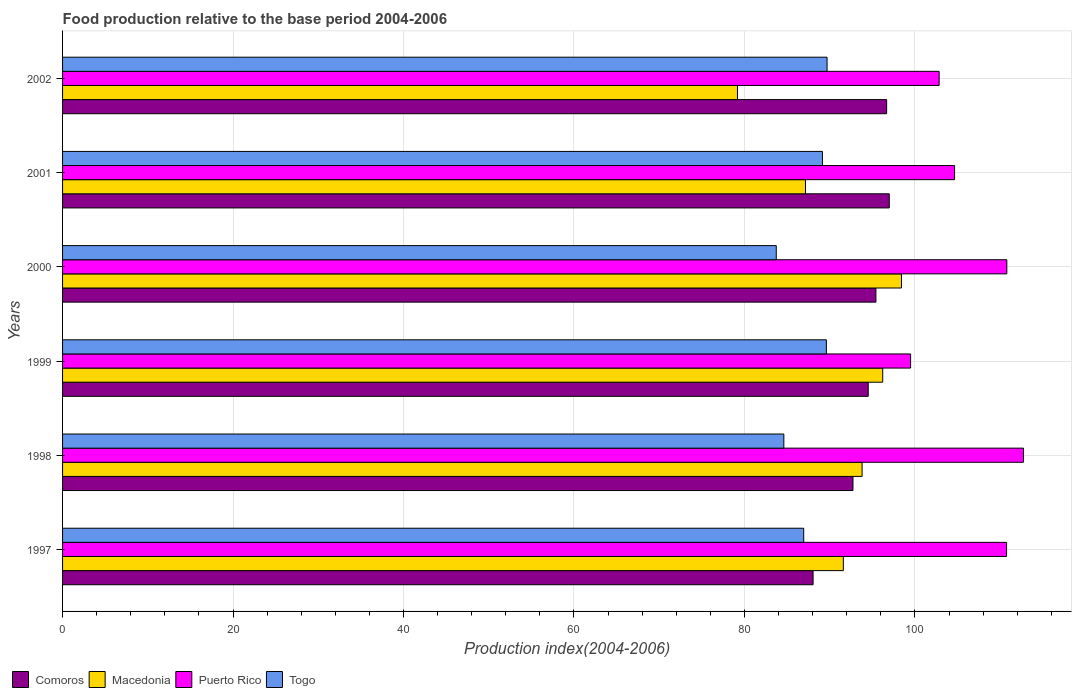How many groups of bars are there?
Your answer should be compact. 6. How many bars are there on the 1st tick from the top?
Your response must be concise. 4. What is the food production index in Comoros in 1999?
Your answer should be very brief. 94.52. Across all years, what is the maximum food production index in Togo?
Provide a short and direct response. 89.69. Across all years, what is the minimum food production index in Puerto Rico?
Provide a succinct answer. 99.49. In which year was the food production index in Puerto Rico minimum?
Make the answer very short. 1999. What is the total food production index in Puerto Rico in the graph?
Your answer should be very brief. 641.24. What is the difference between the food production index in Macedonia in 1998 and that in 1999?
Provide a succinct answer. -2.42. What is the difference between the food production index in Puerto Rico in 1999 and the food production index in Macedonia in 2001?
Your answer should be very brief. 12.33. What is the average food production index in Macedonia per year?
Your response must be concise. 91.06. In the year 2001, what is the difference between the food production index in Comoros and food production index in Puerto Rico?
Keep it short and to the point. -7.66. In how many years, is the food production index in Puerto Rico greater than 48 ?
Provide a short and direct response. 6. What is the ratio of the food production index in Togo in 1999 to that in 2002?
Provide a succinct answer. 1. Is the food production index in Comoros in 1998 less than that in 2002?
Ensure brevity in your answer.  Yes. Is the difference between the food production index in Comoros in 1999 and 2002 greater than the difference between the food production index in Puerto Rico in 1999 and 2002?
Offer a terse response. Yes. What is the difference between the highest and the second highest food production index in Macedonia?
Provide a succinct answer. 2.2. What is the difference between the highest and the lowest food production index in Macedonia?
Keep it short and to the point. 19.24. In how many years, is the food production index in Macedonia greater than the average food production index in Macedonia taken over all years?
Provide a succinct answer. 4. Is the sum of the food production index in Puerto Rico in 1998 and 2000 greater than the maximum food production index in Togo across all years?
Provide a short and direct response. Yes. What does the 3rd bar from the top in 1998 represents?
Provide a short and direct response. Macedonia. What does the 3rd bar from the bottom in 1999 represents?
Keep it short and to the point. Puerto Rico. Are all the bars in the graph horizontal?
Offer a terse response. Yes. What is the difference between two consecutive major ticks on the X-axis?
Your response must be concise. 20. What is the title of the graph?
Your response must be concise. Food production relative to the base period 2004-2006. Does "Lithuania" appear as one of the legend labels in the graph?
Your response must be concise. No. What is the label or title of the X-axis?
Your answer should be very brief. Production index(2004-2006). What is the label or title of the Y-axis?
Give a very brief answer. Years. What is the Production index(2004-2006) of Comoros in 1997?
Provide a succinct answer. 88.05. What is the Production index(2004-2006) of Macedonia in 1997?
Your response must be concise. 91.6. What is the Production index(2004-2006) of Puerto Rico in 1997?
Give a very brief answer. 110.75. What is the Production index(2004-2006) in Togo in 1997?
Provide a short and direct response. 86.95. What is the Production index(2004-2006) in Comoros in 1998?
Your answer should be very brief. 92.73. What is the Production index(2004-2006) of Macedonia in 1998?
Provide a short and direct response. 93.8. What is the Production index(2004-2006) of Puerto Rico in 1998?
Ensure brevity in your answer.  112.73. What is the Production index(2004-2006) of Togo in 1998?
Give a very brief answer. 84.62. What is the Production index(2004-2006) in Comoros in 1999?
Provide a short and direct response. 94.52. What is the Production index(2004-2006) of Macedonia in 1999?
Ensure brevity in your answer.  96.22. What is the Production index(2004-2006) of Puerto Rico in 1999?
Offer a very short reply. 99.49. What is the Production index(2004-2006) in Togo in 1999?
Offer a terse response. 89.61. What is the Production index(2004-2006) in Comoros in 2000?
Your answer should be compact. 95.42. What is the Production index(2004-2006) in Macedonia in 2000?
Make the answer very short. 98.42. What is the Production index(2004-2006) of Puerto Rico in 2000?
Provide a short and direct response. 110.78. What is the Production index(2004-2006) in Togo in 2000?
Offer a terse response. 83.73. What is the Production index(2004-2006) in Comoros in 2001?
Make the answer very short. 96.99. What is the Production index(2004-2006) of Macedonia in 2001?
Keep it short and to the point. 87.16. What is the Production index(2004-2006) of Puerto Rico in 2001?
Your answer should be very brief. 104.65. What is the Production index(2004-2006) of Togo in 2001?
Keep it short and to the point. 89.15. What is the Production index(2004-2006) of Comoros in 2002?
Your response must be concise. 96.68. What is the Production index(2004-2006) of Macedonia in 2002?
Give a very brief answer. 79.18. What is the Production index(2004-2006) in Puerto Rico in 2002?
Ensure brevity in your answer.  102.84. What is the Production index(2004-2006) of Togo in 2002?
Offer a terse response. 89.69. Across all years, what is the maximum Production index(2004-2006) of Comoros?
Give a very brief answer. 96.99. Across all years, what is the maximum Production index(2004-2006) in Macedonia?
Offer a terse response. 98.42. Across all years, what is the maximum Production index(2004-2006) of Puerto Rico?
Make the answer very short. 112.73. Across all years, what is the maximum Production index(2004-2006) of Togo?
Offer a very short reply. 89.69. Across all years, what is the minimum Production index(2004-2006) in Comoros?
Ensure brevity in your answer.  88.05. Across all years, what is the minimum Production index(2004-2006) of Macedonia?
Provide a succinct answer. 79.18. Across all years, what is the minimum Production index(2004-2006) of Puerto Rico?
Your response must be concise. 99.49. Across all years, what is the minimum Production index(2004-2006) of Togo?
Your answer should be very brief. 83.73. What is the total Production index(2004-2006) of Comoros in the graph?
Offer a very short reply. 564.39. What is the total Production index(2004-2006) in Macedonia in the graph?
Offer a very short reply. 546.38. What is the total Production index(2004-2006) in Puerto Rico in the graph?
Make the answer very short. 641.24. What is the total Production index(2004-2006) in Togo in the graph?
Make the answer very short. 523.75. What is the difference between the Production index(2004-2006) in Comoros in 1997 and that in 1998?
Offer a very short reply. -4.68. What is the difference between the Production index(2004-2006) of Macedonia in 1997 and that in 1998?
Offer a terse response. -2.2. What is the difference between the Production index(2004-2006) of Puerto Rico in 1997 and that in 1998?
Your answer should be compact. -1.98. What is the difference between the Production index(2004-2006) of Togo in 1997 and that in 1998?
Your answer should be compact. 2.33. What is the difference between the Production index(2004-2006) of Comoros in 1997 and that in 1999?
Your response must be concise. -6.47. What is the difference between the Production index(2004-2006) in Macedonia in 1997 and that in 1999?
Your answer should be very brief. -4.62. What is the difference between the Production index(2004-2006) of Puerto Rico in 1997 and that in 1999?
Your response must be concise. 11.26. What is the difference between the Production index(2004-2006) of Togo in 1997 and that in 1999?
Offer a terse response. -2.66. What is the difference between the Production index(2004-2006) in Comoros in 1997 and that in 2000?
Your answer should be compact. -7.37. What is the difference between the Production index(2004-2006) of Macedonia in 1997 and that in 2000?
Ensure brevity in your answer.  -6.82. What is the difference between the Production index(2004-2006) in Puerto Rico in 1997 and that in 2000?
Your answer should be compact. -0.03. What is the difference between the Production index(2004-2006) of Togo in 1997 and that in 2000?
Provide a succinct answer. 3.22. What is the difference between the Production index(2004-2006) in Comoros in 1997 and that in 2001?
Offer a very short reply. -8.94. What is the difference between the Production index(2004-2006) in Macedonia in 1997 and that in 2001?
Your answer should be compact. 4.44. What is the difference between the Production index(2004-2006) in Comoros in 1997 and that in 2002?
Ensure brevity in your answer.  -8.63. What is the difference between the Production index(2004-2006) of Macedonia in 1997 and that in 2002?
Your answer should be very brief. 12.42. What is the difference between the Production index(2004-2006) of Puerto Rico in 1997 and that in 2002?
Provide a short and direct response. 7.91. What is the difference between the Production index(2004-2006) of Togo in 1997 and that in 2002?
Keep it short and to the point. -2.74. What is the difference between the Production index(2004-2006) of Comoros in 1998 and that in 1999?
Offer a terse response. -1.79. What is the difference between the Production index(2004-2006) in Macedonia in 1998 and that in 1999?
Provide a succinct answer. -2.42. What is the difference between the Production index(2004-2006) of Puerto Rico in 1998 and that in 1999?
Offer a very short reply. 13.24. What is the difference between the Production index(2004-2006) of Togo in 1998 and that in 1999?
Your answer should be very brief. -4.99. What is the difference between the Production index(2004-2006) of Comoros in 1998 and that in 2000?
Your answer should be very brief. -2.69. What is the difference between the Production index(2004-2006) of Macedonia in 1998 and that in 2000?
Keep it short and to the point. -4.62. What is the difference between the Production index(2004-2006) in Puerto Rico in 1998 and that in 2000?
Your response must be concise. 1.95. What is the difference between the Production index(2004-2006) of Togo in 1998 and that in 2000?
Provide a succinct answer. 0.89. What is the difference between the Production index(2004-2006) of Comoros in 1998 and that in 2001?
Your response must be concise. -4.26. What is the difference between the Production index(2004-2006) in Macedonia in 1998 and that in 2001?
Your answer should be very brief. 6.64. What is the difference between the Production index(2004-2006) in Puerto Rico in 1998 and that in 2001?
Your response must be concise. 8.08. What is the difference between the Production index(2004-2006) in Togo in 1998 and that in 2001?
Ensure brevity in your answer.  -4.53. What is the difference between the Production index(2004-2006) in Comoros in 1998 and that in 2002?
Provide a short and direct response. -3.95. What is the difference between the Production index(2004-2006) of Macedonia in 1998 and that in 2002?
Make the answer very short. 14.62. What is the difference between the Production index(2004-2006) in Puerto Rico in 1998 and that in 2002?
Offer a terse response. 9.89. What is the difference between the Production index(2004-2006) in Togo in 1998 and that in 2002?
Keep it short and to the point. -5.07. What is the difference between the Production index(2004-2006) in Macedonia in 1999 and that in 2000?
Ensure brevity in your answer.  -2.2. What is the difference between the Production index(2004-2006) in Puerto Rico in 1999 and that in 2000?
Keep it short and to the point. -11.29. What is the difference between the Production index(2004-2006) of Togo in 1999 and that in 2000?
Offer a terse response. 5.88. What is the difference between the Production index(2004-2006) in Comoros in 1999 and that in 2001?
Keep it short and to the point. -2.47. What is the difference between the Production index(2004-2006) in Macedonia in 1999 and that in 2001?
Offer a terse response. 9.06. What is the difference between the Production index(2004-2006) in Puerto Rico in 1999 and that in 2001?
Your response must be concise. -5.16. What is the difference between the Production index(2004-2006) of Togo in 1999 and that in 2001?
Offer a very short reply. 0.46. What is the difference between the Production index(2004-2006) of Comoros in 1999 and that in 2002?
Provide a succinct answer. -2.16. What is the difference between the Production index(2004-2006) in Macedonia in 1999 and that in 2002?
Provide a succinct answer. 17.04. What is the difference between the Production index(2004-2006) of Puerto Rico in 1999 and that in 2002?
Ensure brevity in your answer.  -3.35. What is the difference between the Production index(2004-2006) in Togo in 1999 and that in 2002?
Make the answer very short. -0.08. What is the difference between the Production index(2004-2006) in Comoros in 2000 and that in 2001?
Your answer should be compact. -1.57. What is the difference between the Production index(2004-2006) of Macedonia in 2000 and that in 2001?
Provide a short and direct response. 11.26. What is the difference between the Production index(2004-2006) in Puerto Rico in 2000 and that in 2001?
Ensure brevity in your answer.  6.13. What is the difference between the Production index(2004-2006) of Togo in 2000 and that in 2001?
Your response must be concise. -5.42. What is the difference between the Production index(2004-2006) of Comoros in 2000 and that in 2002?
Your response must be concise. -1.26. What is the difference between the Production index(2004-2006) of Macedonia in 2000 and that in 2002?
Offer a very short reply. 19.24. What is the difference between the Production index(2004-2006) in Puerto Rico in 2000 and that in 2002?
Offer a very short reply. 7.94. What is the difference between the Production index(2004-2006) of Togo in 2000 and that in 2002?
Provide a succinct answer. -5.96. What is the difference between the Production index(2004-2006) in Comoros in 2001 and that in 2002?
Provide a short and direct response. 0.31. What is the difference between the Production index(2004-2006) of Macedonia in 2001 and that in 2002?
Make the answer very short. 7.98. What is the difference between the Production index(2004-2006) of Puerto Rico in 2001 and that in 2002?
Provide a short and direct response. 1.81. What is the difference between the Production index(2004-2006) in Togo in 2001 and that in 2002?
Provide a short and direct response. -0.54. What is the difference between the Production index(2004-2006) in Comoros in 1997 and the Production index(2004-2006) in Macedonia in 1998?
Offer a terse response. -5.75. What is the difference between the Production index(2004-2006) of Comoros in 1997 and the Production index(2004-2006) of Puerto Rico in 1998?
Give a very brief answer. -24.68. What is the difference between the Production index(2004-2006) of Comoros in 1997 and the Production index(2004-2006) of Togo in 1998?
Ensure brevity in your answer.  3.43. What is the difference between the Production index(2004-2006) in Macedonia in 1997 and the Production index(2004-2006) in Puerto Rico in 1998?
Your answer should be compact. -21.13. What is the difference between the Production index(2004-2006) of Macedonia in 1997 and the Production index(2004-2006) of Togo in 1998?
Provide a succinct answer. 6.98. What is the difference between the Production index(2004-2006) in Puerto Rico in 1997 and the Production index(2004-2006) in Togo in 1998?
Keep it short and to the point. 26.13. What is the difference between the Production index(2004-2006) in Comoros in 1997 and the Production index(2004-2006) in Macedonia in 1999?
Ensure brevity in your answer.  -8.17. What is the difference between the Production index(2004-2006) of Comoros in 1997 and the Production index(2004-2006) of Puerto Rico in 1999?
Your answer should be compact. -11.44. What is the difference between the Production index(2004-2006) of Comoros in 1997 and the Production index(2004-2006) of Togo in 1999?
Your answer should be compact. -1.56. What is the difference between the Production index(2004-2006) of Macedonia in 1997 and the Production index(2004-2006) of Puerto Rico in 1999?
Offer a terse response. -7.89. What is the difference between the Production index(2004-2006) of Macedonia in 1997 and the Production index(2004-2006) of Togo in 1999?
Keep it short and to the point. 1.99. What is the difference between the Production index(2004-2006) in Puerto Rico in 1997 and the Production index(2004-2006) in Togo in 1999?
Offer a very short reply. 21.14. What is the difference between the Production index(2004-2006) of Comoros in 1997 and the Production index(2004-2006) of Macedonia in 2000?
Your answer should be very brief. -10.37. What is the difference between the Production index(2004-2006) in Comoros in 1997 and the Production index(2004-2006) in Puerto Rico in 2000?
Your response must be concise. -22.73. What is the difference between the Production index(2004-2006) of Comoros in 1997 and the Production index(2004-2006) of Togo in 2000?
Provide a succinct answer. 4.32. What is the difference between the Production index(2004-2006) in Macedonia in 1997 and the Production index(2004-2006) in Puerto Rico in 2000?
Give a very brief answer. -19.18. What is the difference between the Production index(2004-2006) of Macedonia in 1997 and the Production index(2004-2006) of Togo in 2000?
Your response must be concise. 7.87. What is the difference between the Production index(2004-2006) of Puerto Rico in 1997 and the Production index(2004-2006) of Togo in 2000?
Provide a succinct answer. 27.02. What is the difference between the Production index(2004-2006) of Comoros in 1997 and the Production index(2004-2006) of Macedonia in 2001?
Make the answer very short. 0.89. What is the difference between the Production index(2004-2006) of Comoros in 1997 and the Production index(2004-2006) of Puerto Rico in 2001?
Provide a succinct answer. -16.6. What is the difference between the Production index(2004-2006) in Comoros in 1997 and the Production index(2004-2006) in Togo in 2001?
Offer a terse response. -1.1. What is the difference between the Production index(2004-2006) of Macedonia in 1997 and the Production index(2004-2006) of Puerto Rico in 2001?
Ensure brevity in your answer.  -13.05. What is the difference between the Production index(2004-2006) of Macedonia in 1997 and the Production index(2004-2006) of Togo in 2001?
Provide a succinct answer. 2.45. What is the difference between the Production index(2004-2006) in Puerto Rico in 1997 and the Production index(2004-2006) in Togo in 2001?
Your answer should be very brief. 21.6. What is the difference between the Production index(2004-2006) of Comoros in 1997 and the Production index(2004-2006) of Macedonia in 2002?
Your response must be concise. 8.87. What is the difference between the Production index(2004-2006) of Comoros in 1997 and the Production index(2004-2006) of Puerto Rico in 2002?
Your answer should be compact. -14.79. What is the difference between the Production index(2004-2006) in Comoros in 1997 and the Production index(2004-2006) in Togo in 2002?
Ensure brevity in your answer.  -1.64. What is the difference between the Production index(2004-2006) of Macedonia in 1997 and the Production index(2004-2006) of Puerto Rico in 2002?
Make the answer very short. -11.24. What is the difference between the Production index(2004-2006) in Macedonia in 1997 and the Production index(2004-2006) in Togo in 2002?
Your answer should be very brief. 1.91. What is the difference between the Production index(2004-2006) in Puerto Rico in 1997 and the Production index(2004-2006) in Togo in 2002?
Your answer should be very brief. 21.06. What is the difference between the Production index(2004-2006) in Comoros in 1998 and the Production index(2004-2006) in Macedonia in 1999?
Your response must be concise. -3.49. What is the difference between the Production index(2004-2006) of Comoros in 1998 and the Production index(2004-2006) of Puerto Rico in 1999?
Offer a very short reply. -6.76. What is the difference between the Production index(2004-2006) in Comoros in 1998 and the Production index(2004-2006) in Togo in 1999?
Provide a short and direct response. 3.12. What is the difference between the Production index(2004-2006) in Macedonia in 1998 and the Production index(2004-2006) in Puerto Rico in 1999?
Your answer should be compact. -5.69. What is the difference between the Production index(2004-2006) of Macedonia in 1998 and the Production index(2004-2006) of Togo in 1999?
Provide a short and direct response. 4.19. What is the difference between the Production index(2004-2006) in Puerto Rico in 1998 and the Production index(2004-2006) in Togo in 1999?
Your response must be concise. 23.12. What is the difference between the Production index(2004-2006) of Comoros in 1998 and the Production index(2004-2006) of Macedonia in 2000?
Offer a very short reply. -5.69. What is the difference between the Production index(2004-2006) of Comoros in 1998 and the Production index(2004-2006) of Puerto Rico in 2000?
Keep it short and to the point. -18.05. What is the difference between the Production index(2004-2006) in Comoros in 1998 and the Production index(2004-2006) in Togo in 2000?
Your answer should be very brief. 9. What is the difference between the Production index(2004-2006) in Macedonia in 1998 and the Production index(2004-2006) in Puerto Rico in 2000?
Your answer should be compact. -16.98. What is the difference between the Production index(2004-2006) in Macedonia in 1998 and the Production index(2004-2006) in Togo in 2000?
Offer a terse response. 10.07. What is the difference between the Production index(2004-2006) in Comoros in 1998 and the Production index(2004-2006) in Macedonia in 2001?
Keep it short and to the point. 5.57. What is the difference between the Production index(2004-2006) in Comoros in 1998 and the Production index(2004-2006) in Puerto Rico in 2001?
Your response must be concise. -11.92. What is the difference between the Production index(2004-2006) of Comoros in 1998 and the Production index(2004-2006) of Togo in 2001?
Your answer should be very brief. 3.58. What is the difference between the Production index(2004-2006) in Macedonia in 1998 and the Production index(2004-2006) in Puerto Rico in 2001?
Keep it short and to the point. -10.85. What is the difference between the Production index(2004-2006) in Macedonia in 1998 and the Production index(2004-2006) in Togo in 2001?
Make the answer very short. 4.65. What is the difference between the Production index(2004-2006) of Puerto Rico in 1998 and the Production index(2004-2006) of Togo in 2001?
Offer a very short reply. 23.58. What is the difference between the Production index(2004-2006) in Comoros in 1998 and the Production index(2004-2006) in Macedonia in 2002?
Your response must be concise. 13.55. What is the difference between the Production index(2004-2006) in Comoros in 1998 and the Production index(2004-2006) in Puerto Rico in 2002?
Offer a terse response. -10.11. What is the difference between the Production index(2004-2006) in Comoros in 1998 and the Production index(2004-2006) in Togo in 2002?
Offer a terse response. 3.04. What is the difference between the Production index(2004-2006) of Macedonia in 1998 and the Production index(2004-2006) of Puerto Rico in 2002?
Provide a succinct answer. -9.04. What is the difference between the Production index(2004-2006) in Macedonia in 1998 and the Production index(2004-2006) in Togo in 2002?
Give a very brief answer. 4.11. What is the difference between the Production index(2004-2006) in Puerto Rico in 1998 and the Production index(2004-2006) in Togo in 2002?
Offer a very short reply. 23.04. What is the difference between the Production index(2004-2006) in Comoros in 1999 and the Production index(2004-2006) in Macedonia in 2000?
Your response must be concise. -3.9. What is the difference between the Production index(2004-2006) of Comoros in 1999 and the Production index(2004-2006) of Puerto Rico in 2000?
Keep it short and to the point. -16.26. What is the difference between the Production index(2004-2006) in Comoros in 1999 and the Production index(2004-2006) in Togo in 2000?
Make the answer very short. 10.79. What is the difference between the Production index(2004-2006) of Macedonia in 1999 and the Production index(2004-2006) of Puerto Rico in 2000?
Offer a terse response. -14.56. What is the difference between the Production index(2004-2006) of Macedonia in 1999 and the Production index(2004-2006) of Togo in 2000?
Your answer should be compact. 12.49. What is the difference between the Production index(2004-2006) of Puerto Rico in 1999 and the Production index(2004-2006) of Togo in 2000?
Ensure brevity in your answer.  15.76. What is the difference between the Production index(2004-2006) of Comoros in 1999 and the Production index(2004-2006) of Macedonia in 2001?
Your answer should be compact. 7.36. What is the difference between the Production index(2004-2006) of Comoros in 1999 and the Production index(2004-2006) of Puerto Rico in 2001?
Offer a very short reply. -10.13. What is the difference between the Production index(2004-2006) of Comoros in 1999 and the Production index(2004-2006) of Togo in 2001?
Provide a short and direct response. 5.37. What is the difference between the Production index(2004-2006) of Macedonia in 1999 and the Production index(2004-2006) of Puerto Rico in 2001?
Offer a very short reply. -8.43. What is the difference between the Production index(2004-2006) of Macedonia in 1999 and the Production index(2004-2006) of Togo in 2001?
Offer a terse response. 7.07. What is the difference between the Production index(2004-2006) of Puerto Rico in 1999 and the Production index(2004-2006) of Togo in 2001?
Make the answer very short. 10.34. What is the difference between the Production index(2004-2006) of Comoros in 1999 and the Production index(2004-2006) of Macedonia in 2002?
Provide a succinct answer. 15.34. What is the difference between the Production index(2004-2006) in Comoros in 1999 and the Production index(2004-2006) in Puerto Rico in 2002?
Provide a succinct answer. -8.32. What is the difference between the Production index(2004-2006) in Comoros in 1999 and the Production index(2004-2006) in Togo in 2002?
Offer a very short reply. 4.83. What is the difference between the Production index(2004-2006) of Macedonia in 1999 and the Production index(2004-2006) of Puerto Rico in 2002?
Provide a succinct answer. -6.62. What is the difference between the Production index(2004-2006) of Macedonia in 1999 and the Production index(2004-2006) of Togo in 2002?
Ensure brevity in your answer.  6.53. What is the difference between the Production index(2004-2006) of Puerto Rico in 1999 and the Production index(2004-2006) of Togo in 2002?
Offer a very short reply. 9.8. What is the difference between the Production index(2004-2006) in Comoros in 2000 and the Production index(2004-2006) in Macedonia in 2001?
Offer a very short reply. 8.26. What is the difference between the Production index(2004-2006) in Comoros in 2000 and the Production index(2004-2006) in Puerto Rico in 2001?
Offer a very short reply. -9.23. What is the difference between the Production index(2004-2006) in Comoros in 2000 and the Production index(2004-2006) in Togo in 2001?
Keep it short and to the point. 6.27. What is the difference between the Production index(2004-2006) in Macedonia in 2000 and the Production index(2004-2006) in Puerto Rico in 2001?
Make the answer very short. -6.23. What is the difference between the Production index(2004-2006) of Macedonia in 2000 and the Production index(2004-2006) of Togo in 2001?
Make the answer very short. 9.27. What is the difference between the Production index(2004-2006) in Puerto Rico in 2000 and the Production index(2004-2006) in Togo in 2001?
Provide a succinct answer. 21.63. What is the difference between the Production index(2004-2006) of Comoros in 2000 and the Production index(2004-2006) of Macedonia in 2002?
Offer a terse response. 16.24. What is the difference between the Production index(2004-2006) in Comoros in 2000 and the Production index(2004-2006) in Puerto Rico in 2002?
Keep it short and to the point. -7.42. What is the difference between the Production index(2004-2006) in Comoros in 2000 and the Production index(2004-2006) in Togo in 2002?
Provide a short and direct response. 5.73. What is the difference between the Production index(2004-2006) in Macedonia in 2000 and the Production index(2004-2006) in Puerto Rico in 2002?
Offer a terse response. -4.42. What is the difference between the Production index(2004-2006) of Macedonia in 2000 and the Production index(2004-2006) of Togo in 2002?
Your answer should be compact. 8.73. What is the difference between the Production index(2004-2006) of Puerto Rico in 2000 and the Production index(2004-2006) of Togo in 2002?
Ensure brevity in your answer.  21.09. What is the difference between the Production index(2004-2006) in Comoros in 2001 and the Production index(2004-2006) in Macedonia in 2002?
Make the answer very short. 17.81. What is the difference between the Production index(2004-2006) in Comoros in 2001 and the Production index(2004-2006) in Puerto Rico in 2002?
Your answer should be compact. -5.85. What is the difference between the Production index(2004-2006) of Comoros in 2001 and the Production index(2004-2006) of Togo in 2002?
Give a very brief answer. 7.3. What is the difference between the Production index(2004-2006) of Macedonia in 2001 and the Production index(2004-2006) of Puerto Rico in 2002?
Provide a succinct answer. -15.68. What is the difference between the Production index(2004-2006) of Macedonia in 2001 and the Production index(2004-2006) of Togo in 2002?
Your answer should be compact. -2.53. What is the difference between the Production index(2004-2006) of Puerto Rico in 2001 and the Production index(2004-2006) of Togo in 2002?
Your answer should be compact. 14.96. What is the average Production index(2004-2006) in Comoros per year?
Offer a very short reply. 94.06. What is the average Production index(2004-2006) in Macedonia per year?
Make the answer very short. 91.06. What is the average Production index(2004-2006) of Puerto Rico per year?
Offer a very short reply. 106.87. What is the average Production index(2004-2006) in Togo per year?
Offer a very short reply. 87.29. In the year 1997, what is the difference between the Production index(2004-2006) of Comoros and Production index(2004-2006) of Macedonia?
Your answer should be very brief. -3.55. In the year 1997, what is the difference between the Production index(2004-2006) in Comoros and Production index(2004-2006) in Puerto Rico?
Make the answer very short. -22.7. In the year 1997, what is the difference between the Production index(2004-2006) of Macedonia and Production index(2004-2006) of Puerto Rico?
Keep it short and to the point. -19.15. In the year 1997, what is the difference between the Production index(2004-2006) in Macedonia and Production index(2004-2006) in Togo?
Offer a very short reply. 4.65. In the year 1997, what is the difference between the Production index(2004-2006) in Puerto Rico and Production index(2004-2006) in Togo?
Give a very brief answer. 23.8. In the year 1998, what is the difference between the Production index(2004-2006) in Comoros and Production index(2004-2006) in Macedonia?
Ensure brevity in your answer.  -1.07. In the year 1998, what is the difference between the Production index(2004-2006) in Comoros and Production index(2004-2006) in Togo?
Give a very brief answer. 8.11. In the year 1998, what is the difference between the Production index(2004-2006) of Macedonia and Production index(2004-2006) of Puerto Rico?
Offer a very short reply. -18.93. In the year 1998, what is the difference between the Production index(2004-2006) of Macedonia and Production index(2004-2006) of Togo?
Keep it short and to the point. 9.18. In the year 1998, what is the difference between the Production index(2004-2006) of Puerto Rico and Production index(2004-2006) of Togo?
Your response must be concise. 28.11. In the year 1999, what is the difference between the Production index(2004-2006) of Comoros and Production index(2004-2006) of Puerto Rico?
Provide a succinct answer. -4.97. In the year 1999, what is the difference between the Production index(2004-2006) in Comoros and Production index(2004-2006) in Togo?
Your response must be concise. 4.91. In the year 1999, what is the difference between the Production index(2004-2006) of Macedonia and Production index(2004-2006) of Puerto Rico?
Offer a terse response. -3.27. In the year 1999, what is the difference between the Production index(2004-2006) in Macedonia and Production index(2004-2006) in Togo?
Offer a terse response. 6.61. In the year 1999, what is the difference between the Production index(2004-2006) of Puerto Rico and Production index(2004-2006) of Togo?
Your answer should be very brief. 9.88. In the year 2000, what is the difference between the Production index(2004-2006) in Comoros and Production index(2004-2006) in Puerto Rico?
Give a very brief answer. -15.36. In the year 2000, what is the difference between the Production index(2004-2006) in Comoros and Production index(2004-2006) in Togo?
Ensure brevity in your answer.  11.69. In the year 2000, what is the difference between the Production index(2004-2006) of Macedonia and Production index(2004-2006) of Puerto Rico?
Provide a succinct answer. -12.36. In the year 2000, what is the difference between the Production index(2004-2006) in Macedonia and Production index(2004-2006) in Togo?
Provide a succinct answer. 14.69. In the year 2000, what is the difference between the Production index(2004-2006) in Puerto Rico and Production index(2004-2006) in Togo?
Offer a very short reply. 27.05. In the year 2001, what is the difference between the Production index(2004-2006) in Comoros and Production index(2004-2006) in Macedonia?
Provide a succinct answer. 9.83. In the year 2001, what is the difference between the Production index(2004-2006) in Comoros and Production index(2004-2006) in Puerto Rico?
Ensure brevity in your answer.  -7.66. In the year 2001, what is the difference between the Production index(2004-2006) in Comoros and Production index(2004-2006) in Togo?
Give a very brief answer. 7.84. In the year 2001, what is the difference between the Production index(2004-2006) in Macedonia and Production index(2004-2006) in Puerto Rico?
Offer a terse response. -17.49. In the year 2001, what is the difference between the Production index(2004-2006) in Macedonia and Production index(2004-2006) in Togo?
Your answer should be compact. -1.99. In the year 2002, what is the difference between the Production index(2004-2006) of Comoros and Production index(2004-2006) of Puerto Rico?
Your answer should be compact. -6.16. In the year 2002, what is the difference between the Production index(2004-2006) in Comoros and Production index(2004-2006) in Togo?
Provide a succinct answer. 6.99. In the year 2002, what is the difference between the Production index(2004-2006) of Macedonia and Production index(2004-2006) of Puerto Rico?
Your answer should be very brief. -23.66. In the year 2002, what is the difference between the Production index(2004-2006) of Macedonia and Production index(2004-2006) of Togo?
Offer a very short reply. -10.51. In the year 2002, what is the difference between the Production index(2004-2006) of Puerto Rico and Production index(2004-2006) of Togo?
Make the answer very short. 13.15. What is the ratio of the Production index(2004-2006) in Comoros in 1997 to that in 1998?
Provide a succinct answer. 0.95. What is the ratio of the Production index(2004-2006) in Macedonia in 1997 to that in 1998?
Make the answer very short. 0.98. What is the ratio of the Production index(2004-2006) of Puerto Rico in 1997 to that in 1998?
Provide a short and direct response. 0.98. What is the ratio of the Production index(2004-2006) of Togo in 1997 to that in 1998?
Keep it short and to the point. 1.03. What is the ratio of the Production index(2004-2006) in Comoros in 1997 to that in 1999?
Make the answer very short. 0.93. What is the ratio of the Production index(2004-2006) in Macedonia in 1997 to that in 1999?
Your response must be concise. 0.95. What is the ratio of the Production index(2004-2006) in Puerto Rico in 1997 to that in 1999?
Offer a very short reply. 1.11. What is the ratio of the Production index(2004-2006) of Togo in 1997 to that in 1999?
Offer a terse response. 0.97. What is the ratio of the Production index(2004-2006) in Comoros in 1997 to that in 2000?
Keep it short and to the point. 0.92. What is the ratio of the Production index(2004-2006) in Macedonia in 1997 to that in 2000?
Your answer should be very brief. 0.93. What is the ratio of the Production index(2004-2006) in Comoros in 1997 to that in 2001?
Make the answer very short. 0.91. What is the ratio of the Production index(2004-2006) of Macedonia in 1997 to that in 2001?
Give a very brief answer. 1.05. What is the ratio of the Production index(2004-2006) of Puerto Rico in 1997 to that in 2001?
Ensure brevity in your answer.  1.06. What is the ratio of the Production index(2004-2006) in Togo in 1997 to that in 2001?
Offer a terse response. 0.98. What is the ratio of the Production index(2004-2006) in Comoros in 1997 to that in 2002?
Your answer should be compact. 0.91. What is the ratio of the Production index(2004-2006) of Macedonia in 1997 to that in 2002?
Offer a very short reply. 1.16. What is the ratio of the Production index(2004-2006) in Puerto Rico in 1997 to that in 2002?
Make the answer very short. 1.08. What is the ratio of the Production index(2004-2006) of Togo in 1997 to that in 2002?
Provide a succinct answer. 0.97. What is the ratio of the Production index(2004-2006) of Comoros in 1998 to that in 1999?
Offer a very short reply. 0.98. What is the ratio of the Production index(2004-2006) in Macedonia in 1998 to that in 1999?
Make the answer very short. 0.97. What is the ratio of the Production index(2004-2006) of Puerto Rico in 1998 to that in 1999?
Your response must be concise. 1.13. What is the ratio of the Production index(2004-2006) of Togo in 1998 to that in 1999?
Your answer should be very brief. 0.94. What is the ratio of the Production index(2004-2006) in Comoros in 1998 to that in 2000?
Offer a very short reply. 0.97. What is the ratio of the Production index(2004-2006) in Macedonia in 1998 to that in 2000?
Ensure brevity in your answer.  0.95. What is the ratio of the Production index(2004-2006) of Puerto Rico in 1998 to that in 2000?
Give a very brief answer. 1.02. What is the ratio of the Production index(2004-2006) in Togo in 1998 to that in 2000?
Keep it short and to the point. 1.01. What is the ratio of the Production index(2004-2006) of Comoros in 1998 to that in 2001?
Provide a short and direct response. 0.96. What is the ratio of the Production index(2004-2006) in Macedonia in 1998 to that in 2001?
Give a very brief answer. 1.08. What is the ratio of the Production index(2004-2006) in Puerto Rico in 1998 to that in 2001?
Keep it short and to the point. 1.08. What is the ratio of the Production index(2004-2006) of Togo in 1998 to that in 2001?
Make the answer very short. 0.95. What is the ratio of the Production index(2004-2006) in Comoros in 1998 to that in 2002?
Make the answer very short. 0.96. What is the ratio of the Production index(2004-2006) in Macedonia in 1998 to that in 2002?
Offer a terse response. 1.18. What is the ratio of the Production index(2004-2006) of Puerto Rico in 1998 to that in 2002?
Keep it short and to the point. 1.1. What is the ratio of the Production index(2004-2006) of Togo in 1998 to that in 2002?
Your answer should be very brief. 0.94. What is the ratio of the Production index(2004-2006) in Comoros in 1999 to that in 2000?
Give a very brief answer. 0.99. What is the ratio of the Production index(2004-2006) in Macedonia in 1999 to that in 2000?
Provide a succinct answer. 0.98. What is the ratio of the Production index(2004-2006) of Puerto Rico in 1999 to that in 2000?
Give a very brief answer. 0.9. What is the ratio of the Production index(2004-2006) in Togo in 1999 to that in 2000?
Provide a short and direct response. 1.07. What is the ratio of the Production index(2004-2006) in Comoros in 1999 to that in 2001?
Keep it short and to the point. 0.97. What is the ratio of the Production index(2004-2006) in Macedonia in 1999 to that in 2001?
Provide a short and direct response. 1.1. What is the ratio of the Production index(2004-2006) in Puerto Rico in 1999 to that in 2001?
Provide a short and direct response. 0.95. What is the ratio of the Production index(2004-2006) in Comoros in 1999 to that in 2002?
Your answer should be compact. 0.98. What is the ratio of the Production index(2004-2006) in Macedonia in 1999 to that in 2002?
Make the answer very short. 1.22. What is the ratio of the Production index(2004-2006) in Puerto Rico in 1999 to that in 2002?
Offer a very short reply. 0.97. What is the ratio of the Production index(2004-2006) of Comoros in 2000 to that in 2001?
Make the answer very short. 0.98. What is the ratio of the Production index(2004-2006) of Macedonia in 2000 to that in 2001?
Give a very brief answer. 1.13. What is the ratio of the Production index(2004-2006) in Puerto Rico in 2000 to that in 2001?
Your answer should be compact. 1.06. What is the ratio of the Production index(2004-2006) of Togo in 2000 to that in 2001?
Your answer should be compact. 0.94. What is the ratio of the Production index(2004-2006) in Comoros in 2000 to that in 2002?
Ensure brevity in your answer.  0.99. What is the ratio of the Production index(2004-2006) in Macedonia in 2000 to that in 2002?
Make the answer very short. 1.24. What is the ratio of the Production index(2004-2006) of Puerto Rico in 2000 to that in 2002?
Ensure brevity in your answer.  1.08. What is the ratio of the Production index(2004-2006) in Togo in 2000 to that in 2002?
Your answer should be compact. 0.93. What is the ratio of the Production index(2004-2006) of Macedonia in 2001 to that in 2002?
Make the answer very short. 1.1. What is the ratio of the Production index(2004-2006) of Puerto Rico in 2001 to that in 2002?
Give a very brief answer. 1.02. What is the difference between the highest and the second highest Production index(2004-2006) in Comoros?
Offer a very short reply. 0.31. What is the difference between the highest and the second highest Production index(2004-2006) of Macedonia?
Keep it short and to the point. 2.2. What is the difference between the highest and the second highest Production index(2004-2006) of Puerto Rico?
Your response must be concise. 1.95. What is the difference between the highest and the second highest Production index(2004-2006) in Togo?
Keep it short and to the point. 0.08. What is the difference between the highest and the lowest Production index(2004-2006) in Comoros?
Ensure brevity in your answer.  8.94. What is the difference between the highest and the lowest Production index(2004-2006) in Macedonia?
Provide a succinct answer. 19.24. What is the difference between the highest and the lowest Production index(2004-2006) of Puerto Rico?
Offer a terse response. 13.24. What is the difference between the highest and the lowest Production index(2004-2006) in Togo?
Ensure brevity in your answer.  5.96. 